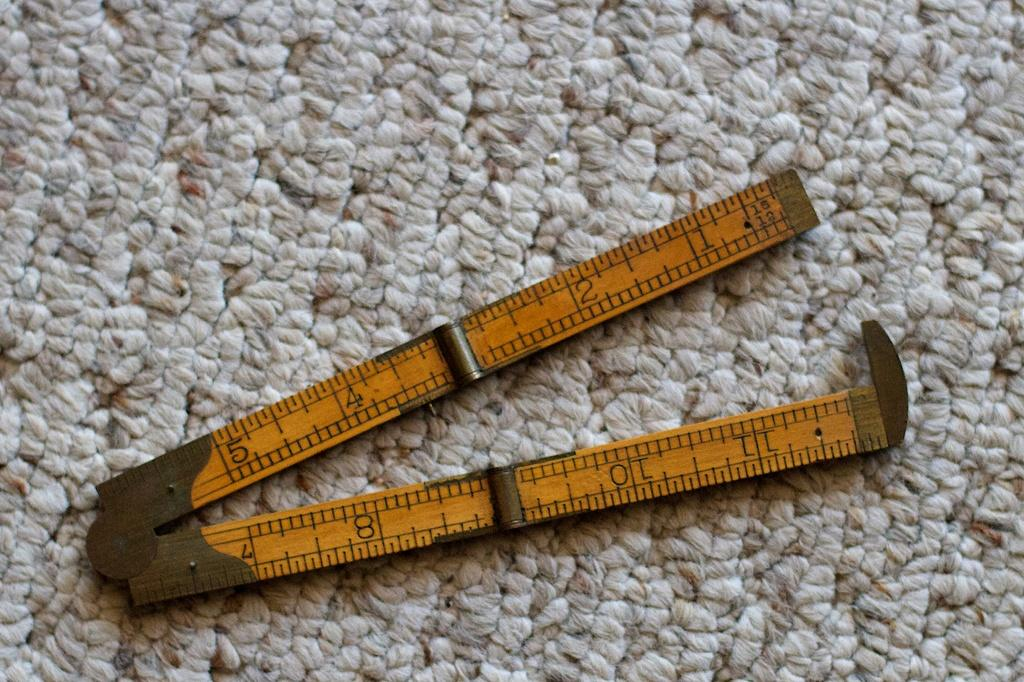<image>
Give a short and clear explanation of the subsequent image. An old ruler with the number 8 showing is open on a floor. 